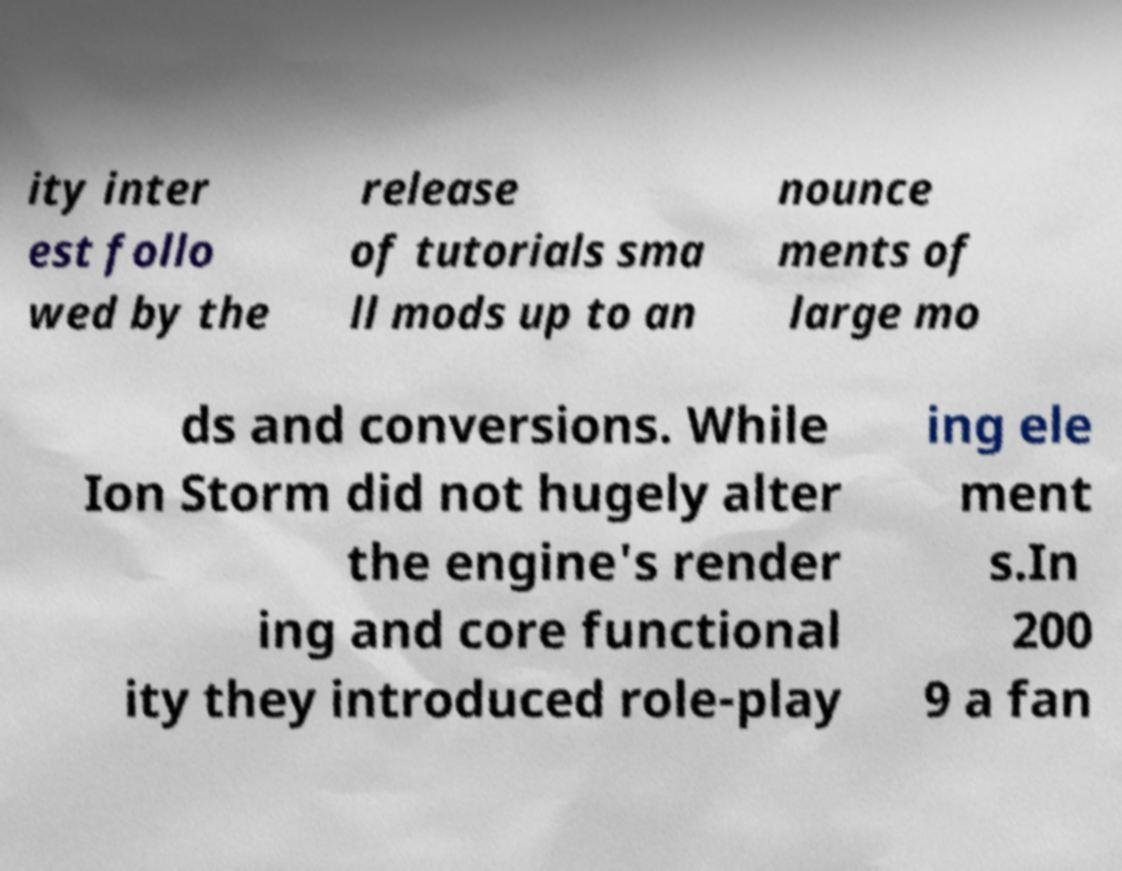What messages or text are displayed in this image? I need them in a readable, typed format. ity inter est follo wed by the release of tutorials sma ll mods up to an nounce ments of large mo ds and conversions. While Ion Storm did not hugely alter the engine's render ing and core functional ity they introduced role-play ing ele ment s.In 200 9 a fan 